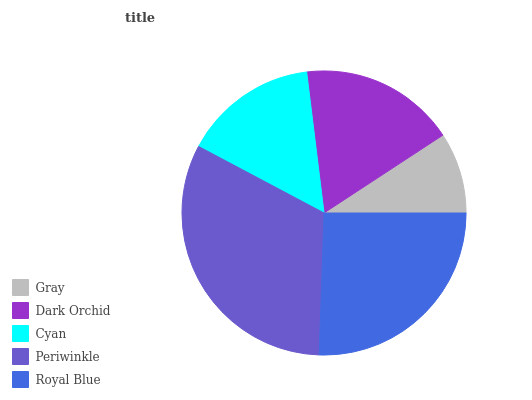Is Gray the minimum?
Answer yes or no. Yes. Is Periwinkle the maximum?
Answer yes or no. Yes. Is Dark Orchid the minimum?
Answer yes or no. No. Is Dark Orchid the maximum?
Answer yes or no. No. Is Dark Orchid greater than Gray?
Answer yes or no. Yes. Is Gray less than Dark Orchid?
Answer yes or no. Yes. Is Gray greater than Dark Orchid?
Answer yes or no. No. Is Dark Orchid less than Gray?
Answer yes or no. No. Is Dark Orchid the high median?
Answer yes or no. Yes. Is Dark Orchid the low median?
Answer yes or no. Yes. Is Periwinkle the high median?
Answer yes or no. No. Is Periwinkle the low median?
Answer yes or no. No. 